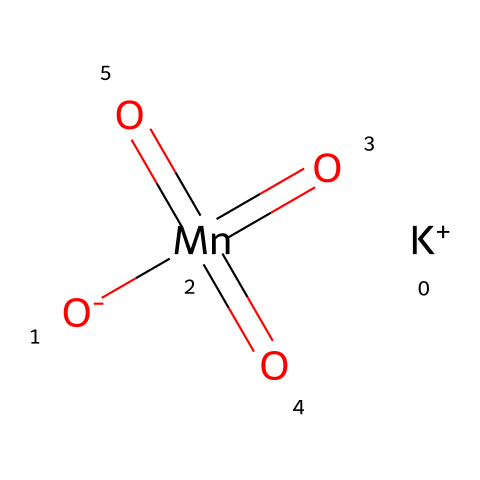How many oxygen atoms are present in potassium permanganate? By analyzing the SMILES representation, we see that there are four oxygen atoms, indicated by the four instances of "O" in the structure.
Answer: four What is the central atom in potassium permanganate? The central atom is manganese, which is represented by "Mn" in the SMILES. It is the element bonded to the oxygen atoms.
Answer: manganese How many oxidation states does manganese exhibit in potassium permanganate? In potassium permanganate, manganese is in a +7 oxidation state, as inferred from its bonding with four oxygen atoms, which are typically in a -2 oxidation state.
Answer: +7 What type of chemical is potassium permanganate categorized as? Potassium permanganate is categorized as an oxidizer, characterized by its ability to accept electrons from other substances.
Answer: oxidizer How many bonds does manganese form with oxygen in this structure? Manganese forms four bonds with oxygen, as seen in the structure where it is connected to four oxygen atoms.
Answer: four What is the charge of the potassium ion in potassium permanganate? The potassium ion (K+) carries a +1 charge, which can be directly observed in the SMILES string where it is depicted as "[K+]".
Answer: +1 What is the role of potassium permanganate in water purification? Potassium permanganate is used as an oxidizing agent in water purification, helping to remove impurities and contaminants by oxidation.
Answer: oxidizing agent 